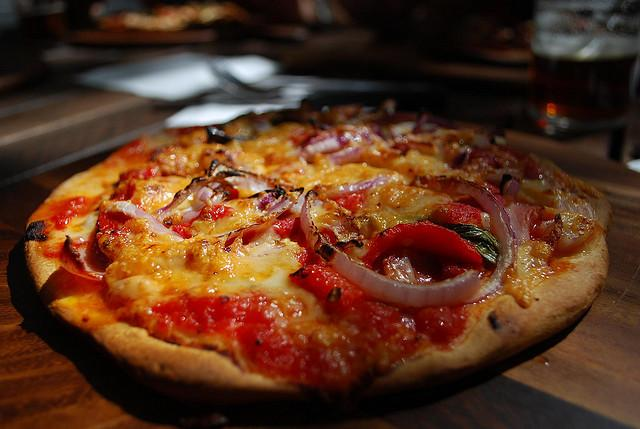The white round item on top of this food is part of what other food item? onion 